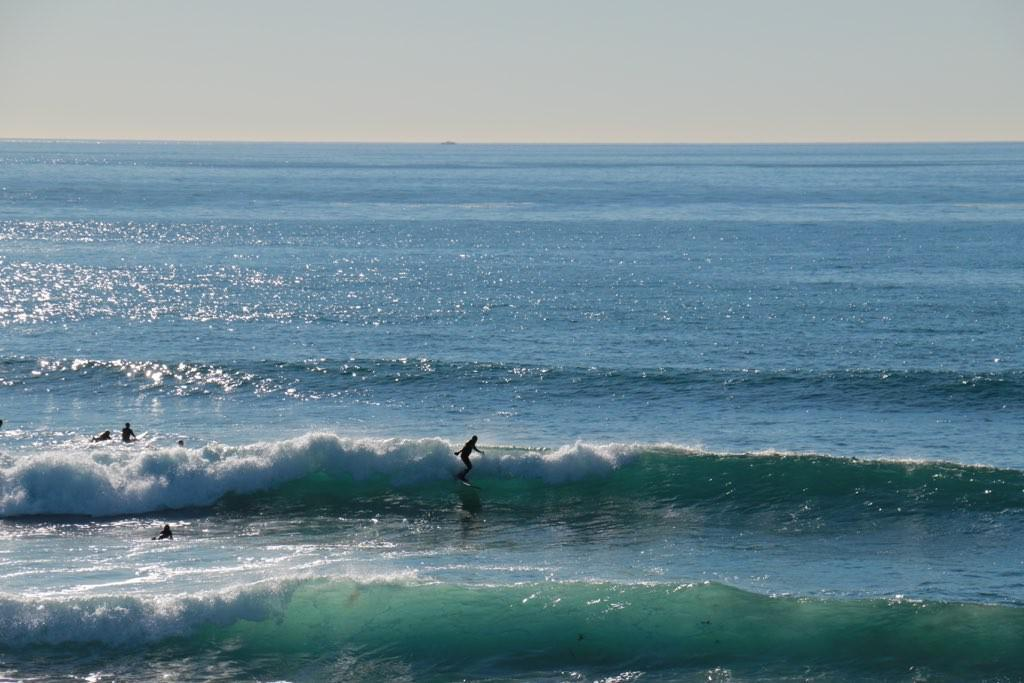What are the people in the image doing? The people in the image are in the water. Can you describe the activity of one of the people in the water? One person is on a surfing board. What can be observed in the water besides the people? Waves are visible in the water. What type of crate is being used to push the waves in the image? There is no crate present in the image, and the waves are not being pushed by any object. 